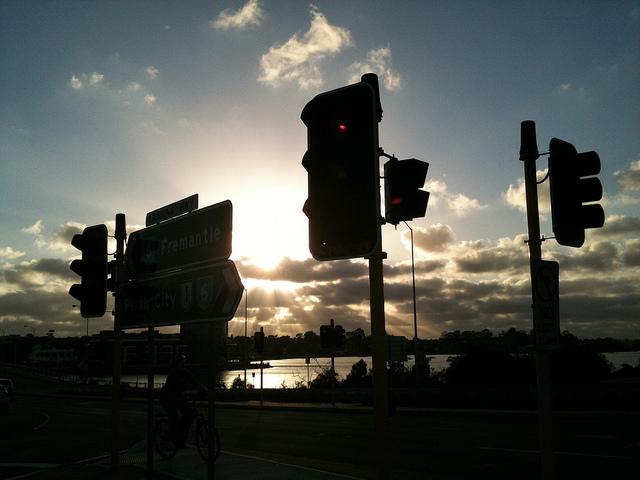Are stars visible in the sky?
Give a very brief answer. No. Is the water calm?
Concise answer only. Yes. What style of photography is demonstrated?
Concise answer only. Sunset. 